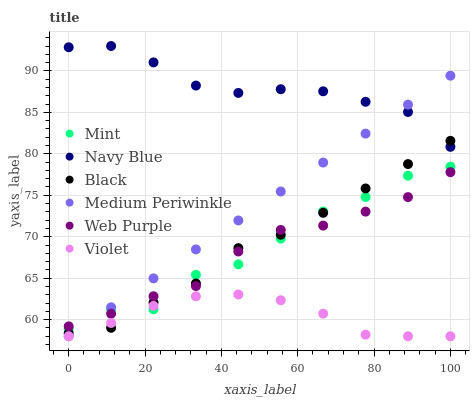Does Violet have the minimum area under the curve?
Answer yes or no. Yes. Does Navy Blue have the maximum area under the curve?
Answer yes or no. Yes. Does Medium Periwinkle have the minimum area under the curve?
Answer yes or no. No. Does Medium Periwinkle have the maximum area under the curve?
Answer yes or no. No. Is Medium Periwinkle the smoothest?
Answer yes or no. Yes. Is Mint the roughest?
Answer yes or no. Yes. Is Web Purple the smoothest?
Answer yes or no. No. Is Web Purple the roughest?
Answer yes or no. No. Does Medium Periwinkle have the lowest value?
Answer yes or no. Yes. Does Web Purple have the lowest value?
Answer yes or no. No. Does Navy Blue have the highest value?
Answer yes or no. Yes. Does Medium Periwinkle have the highest value?
Answer yes or no. No. Is Mint less than Navy Blue?
Answer yes or no. Yes. Is Navy Blue greater than Web Purple?
Answer yes or no. Yes. Does Violet intersect Medium Periwinkle?
Answer yes or no. Yes. Is Violet less than Medium Periwinkle?
Answer yes or no. No. Is Violet greater than Medium Periwinkle?
Answer yes or no. No. Does Mint intersect Navy Blue?
Answer yes or no. No. 